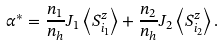Convert formula to latex. <formula><loc_0><loc_0><loc_500><loc_500>\alpha ^ { * } = \frac { n _ { 1 } } { n _ { h } } J _ { 1 } \left < S ^ { z } _ { i _ { 1 } } \right > + \frac { n _ { 2 } } { n _ { h } } J _ { 2 } \left < S ^ { z } _ { i _ { 2 } } \right > .</formula> 